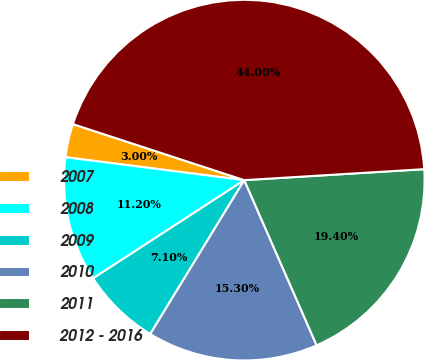Convert chart. <chart><loc_0><loc_0><loc_500><loc_500><pie_chart><fcel>2007<fcel>2008<fcel>2009<fcel>2010<fcel>2011<fcel>2012 - 2016<nl><fcel>3.0%<fcel>11.2%<fcel>7.1%<fcel>15.3%<fcel>19.4%<fcel>44.0%<nl></chart> 